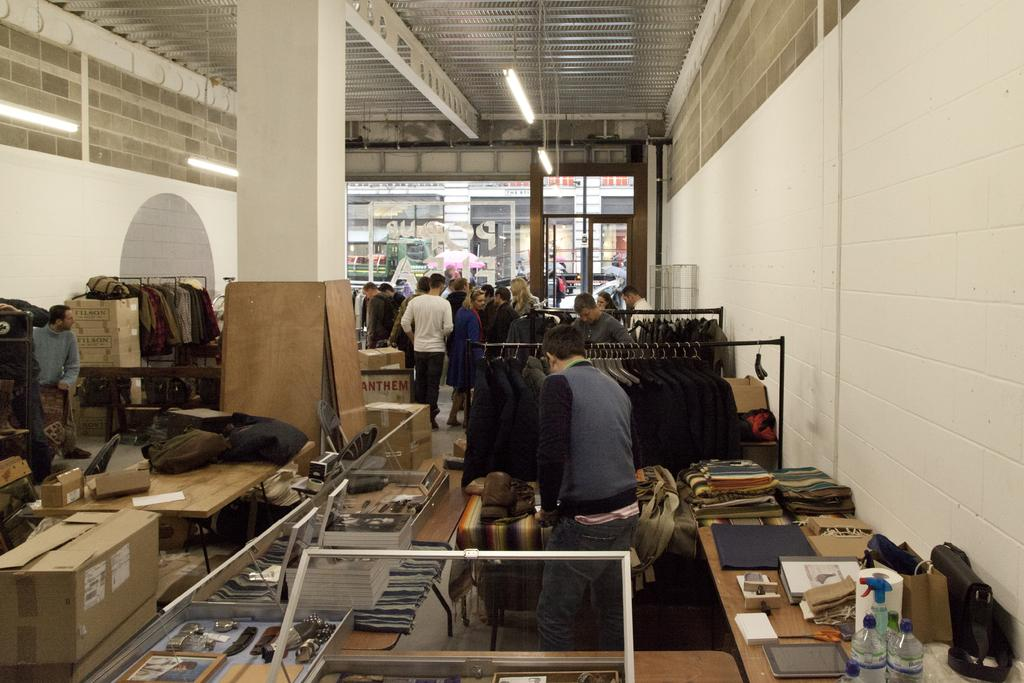How many people are inside the shop in the image? There are several people inside the shop in the image. What are the coats placed on in the shop? The coats are placed on tables in the shop. What else can be seen on the tables in the shop? There are objects placed on tables in the shop. What can be seen in the background of the image? There is a glass door and wooden boxes in the background of the image. What type of noise can be heard coming from the pot in the image? There is no pot present in the image, so it is not possible to determine what, if any, noise might be heard. 